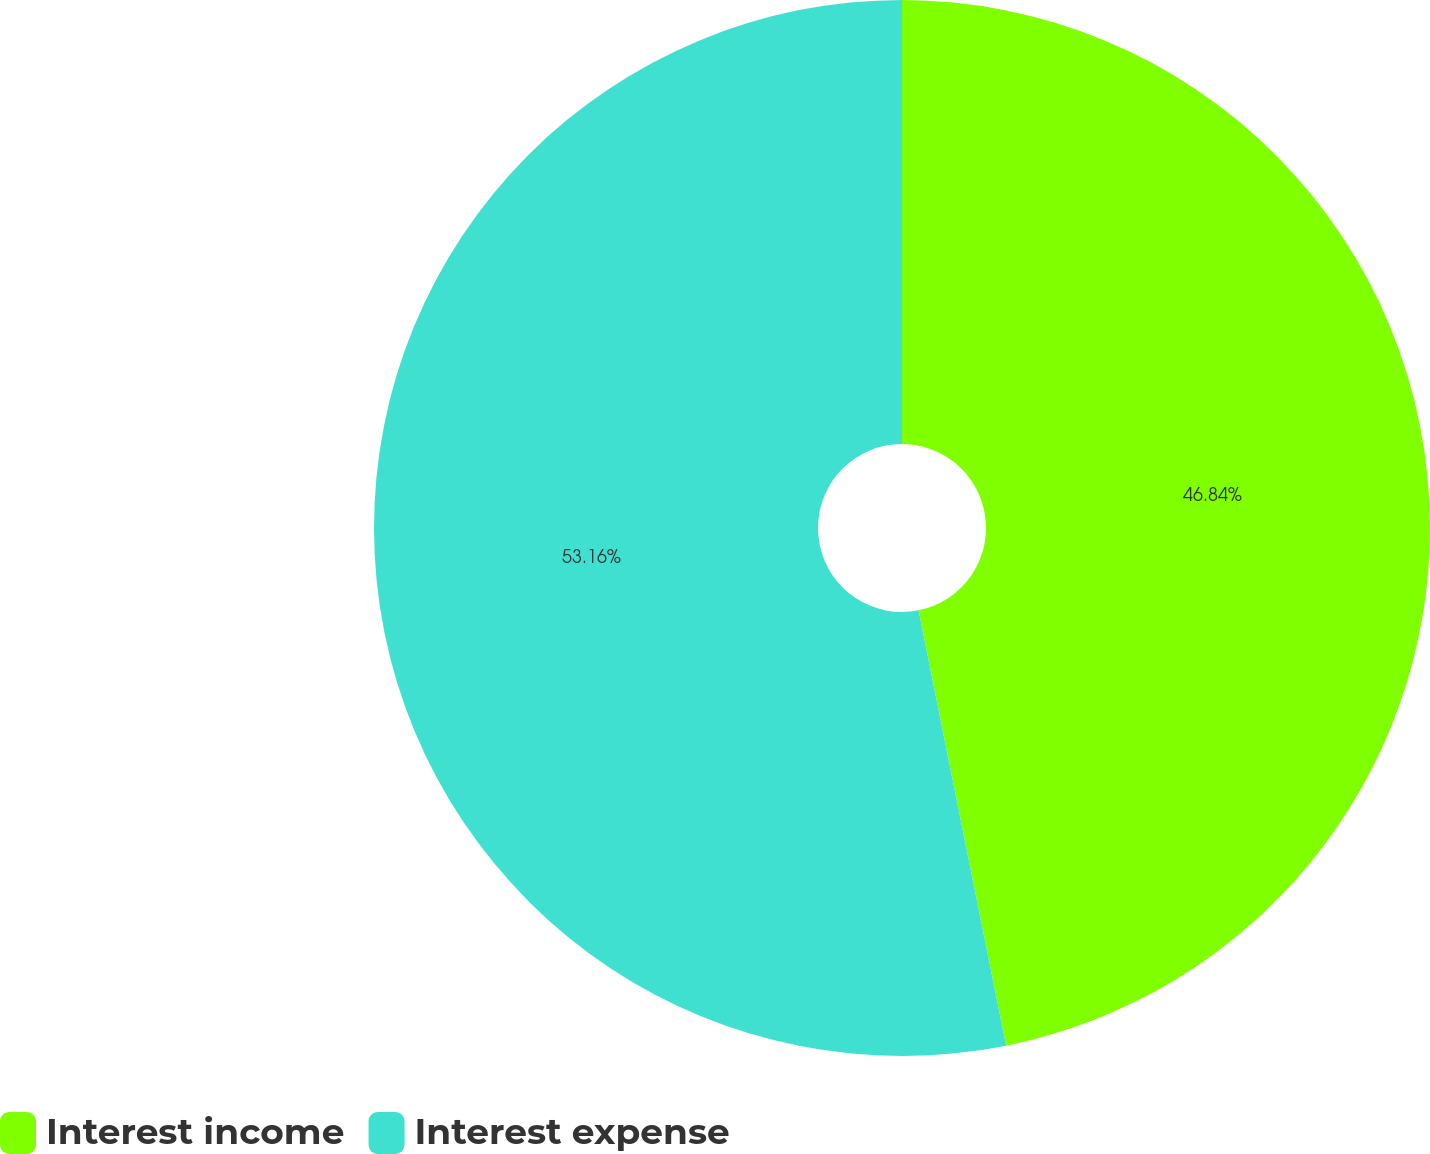Convert chart to OTSL. <chart><loc_0><loc_0><loc_500><loc_500><pie_chart><fcel>Interest income<fcel>Interest expense<nl><fcel>46.84%<fcel>53.16%<nl></chart> 